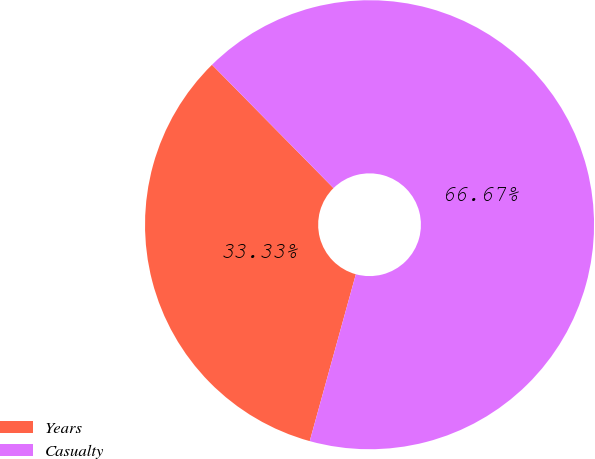Convert chart. <chart><loc_0><loc_0><loc_500><loc_500><pie_chart><fcel>Years<fcel>Casualty<nl><fcel>33.33%<fcel>66.67%<nl></chart> 